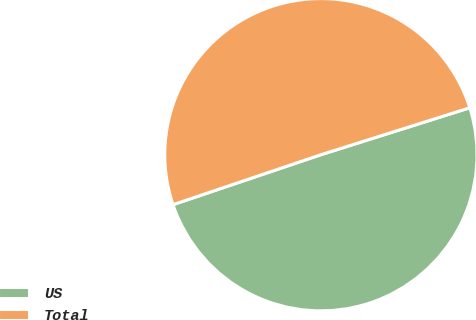Convert chart to OTSL. <chart><loc_0><loc_0><loc_500><loc_500><pie_chart><fcel>US<fcel>Total<nl><fcel>49.68%<fcel>50.32%<nl></chart> 